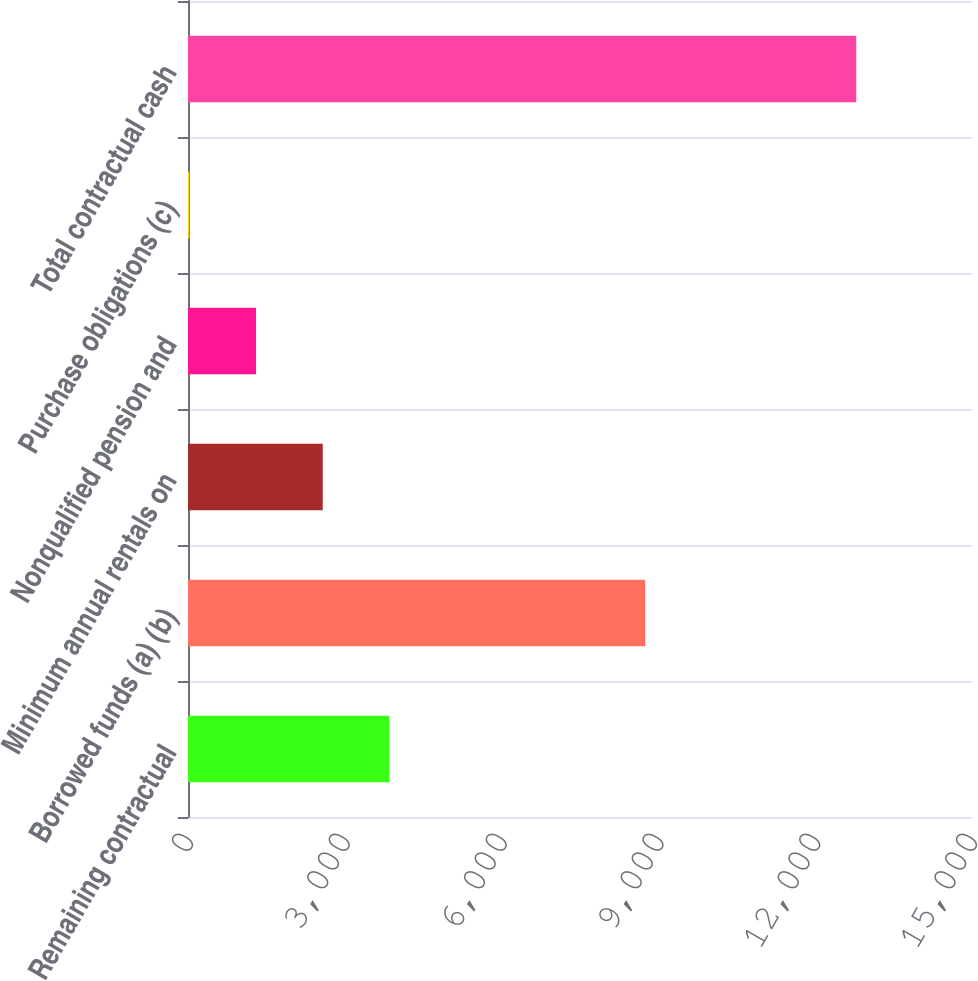Convert chart. <chart><loc_0><loc_0><loc_500><loc_500><bar_chart><fcel>Remaining contractual<fcel>Borrowed funds (a) (b)<fcel>Minimum annual rentals on<fcel>Nonqualified pension and<fcel>Purchase obligations (c)<fcel>Total contractual cash<nl><fcel>3853.7<fcel>8747<fcel>2577.8<fcel>1301.9<fcel>26<fcel>12785<nl></chart> 